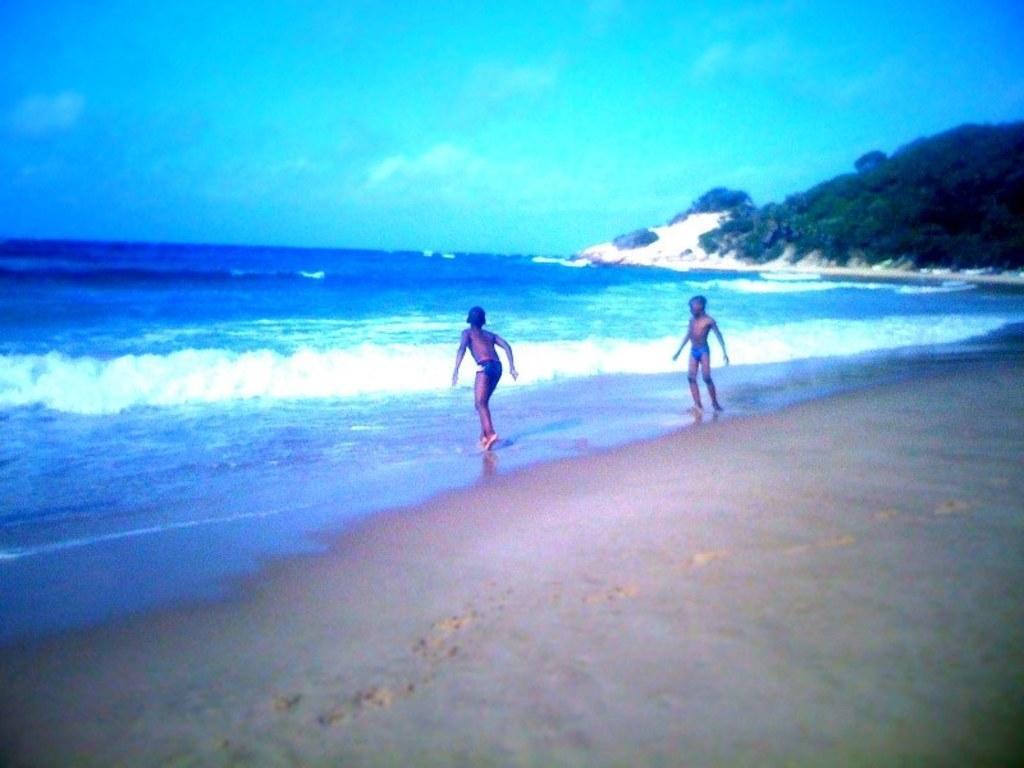Please provide a concise description of this image. This image is clicked at a beach. At the bottom there is the ground. There are two boys standing at the shore. In front of them there is the water. In the background there are mountains. At the top there is the sky. 